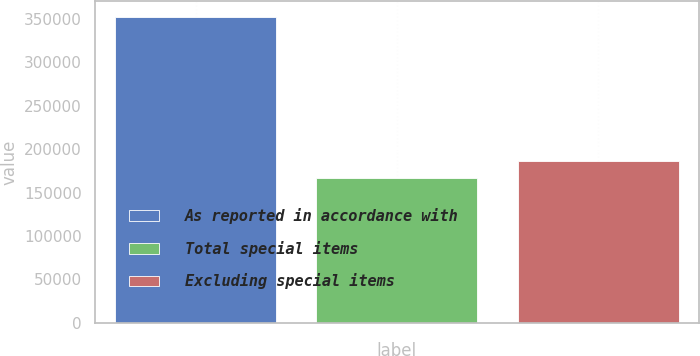Convert chart. <chart><loc_0><loc_0><loc_500><loc_500><bar_chart><fcel>As reported in accordance with<fcel>Total special items<fcel>Excluding special items<nl><fcel>352454<fcel>166485<fcel>185969<nl></chart> 